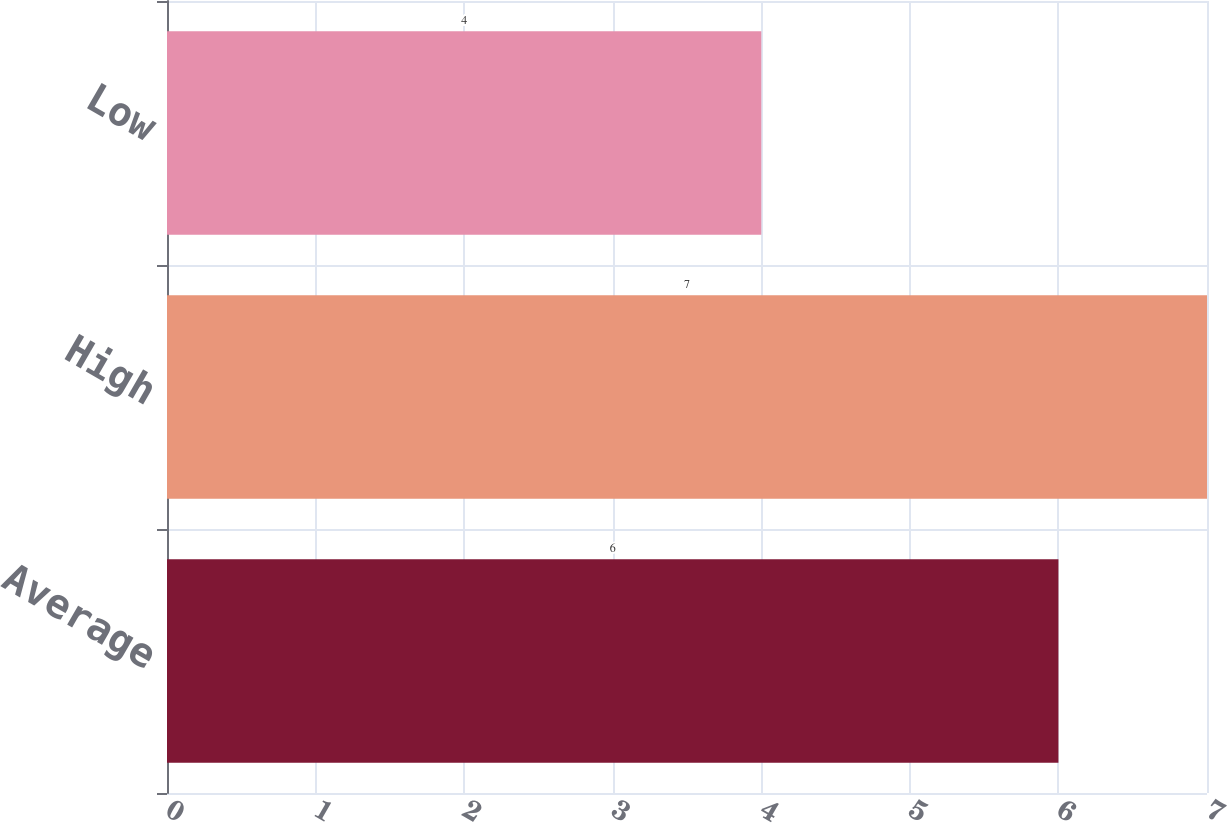Convert chart. <chart><loc_0><loc_0><loc_500><loc_500><bar_chart><fcel>Average<fcel>High<fcel>Low<nl><fcel>6<fcel>7<fcel>4<nl></chart> 